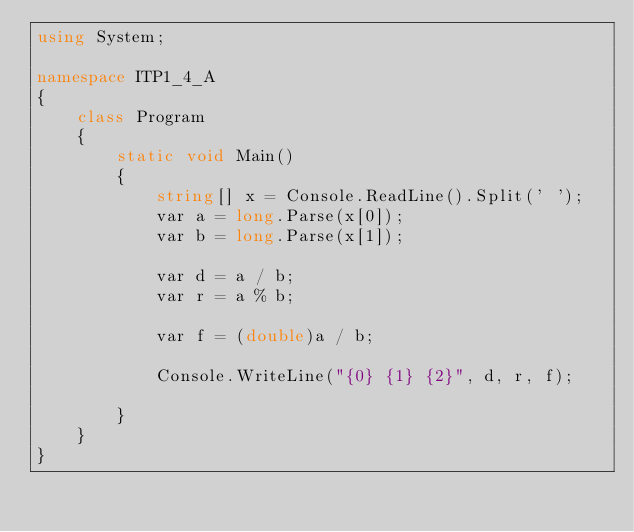Convert code to text. <code><loc_0><loc_0><loc_500><loc_500><_C#_>using System;

namespace ITP1_4_A
{
    class Program
    {
        static void Main()
        {
            string[] x = Console.ReadLine().Split(' ');
            var a = long.Parse(x[0]);
            var b = long.Parse(x[1]);
        
            var d = a / b;
            var r = a % b;
        
            var f = (double)a / b;
        
            Console.WriteLine("{0} {1} {2}", d, r, f);
            
        }
    }
}
</code> 